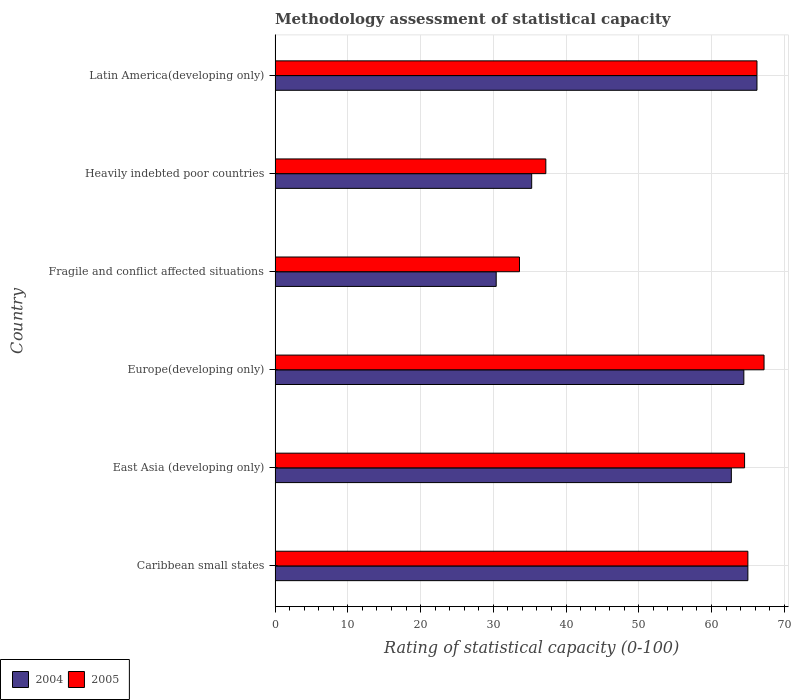Are the number of bars on each tick of the Y-axis equal?
Your answer should be very brief. Yes. How many bars are there on the 4th tick from the top?
Ensure brevity in your answer.  2. What is the label of the 6th group of bars from the top?
Offer a terse response. Caribbean small states. What is the rating of statistical capacity in 2004 in East Asia (developing only)?
Ensure brevity in your answer.  62.73. Across all countries, what is the maximum rating of statistical capacity in 2005?
Provide a short and direct response. 67.22. Across all countries, what is the minimum rating of statistical capacity in 2004?
Keep it short and to the point. 30.4. In which country was the rating of statistical capacity in 2005 maximum?
Make the answer very short. Europe(developing only). In which country was the rating of statistical capacity in 2005 minimum?
Offer a terse response. Fragile and conflict affected situations. What is the total rating of statistical capacity in 2004 in the graph?
Provide a short and direct response. 324.1. What is the difference between the rating of statistical capacity in 2004 in Fragile and conflict affected situations and that in Latin America(developing only)?
Ensure brevity in your answer.  -35.85. What is the difference between the rating of statistical capacity in 2005 in Europe(developing only) and the rating of statistical capacity in 2004 in Fragile and conflict affected situations?
Offer a very short reply. 36.82. What is the average rating of statistical capacity in 2005 per country?
Your response must be concise. 55.64. What is the difference between the rating of statistical capacity in 2004 and rating of statistical capacity in 2005 in Heavily indebted poor countries?
Your answer should be very brief. -1.94. In how many countries, is the rating of statistical capacity in 2004 greater than 56 ?
Your answer should be compact. 4. What is the ratio of the rating of statistical capacity in 2004 in East Asia (developing only) to that in Europe(developing only)?
Your response must be concise. 0.97. What is the difference between the highest and the lowest rating of statistical capacity in 2005?
Keep it short and to the point. 33.62. What does the 1st bar from the bottom in Latin America(developing only) represents?
Offer a terse response. 2004. How many countries are there in the graph?
Offer a very short reply. 6. Are the values on the major ticks of X-axis written in scientific E-notation?
Your answer should be compact. No. Does the graph contain any zero values?
Provide a succinct answer. No. Does the graph contain grids?
Provide a succinct answer. Yes. What is the title of the graph?
Ensure brevity in your answer.  Methodology assessment of statistical capacity. What is the label or title of the X-axis?
Give a very brief answer. Rating of statistical capacity (0-100). What is the label or title of the Y-axis?
Offer a terse response. Country. What is the Rating of statistical capacity (0-100) of 2005 in Caribbean small states?
Provide a succinct answer. 65. What is the Rating of statistical capacity (0-100) of 2004 in East Asia (developing only)?
Your response must be concise. 62.73. What is the Rating of statistical capacity (0-100) in 2005 in East Asia (developing only)?
Keep it short and to the point. 64.55. What is the Rating of statistical capacity (0-100) of 2004 in Europe(developing only)?
Ensure brevity in your answer.  64.44. What is the Rating of statistical capacity (0-100) of 2005 in Europe(developing only)?
Give a very brief answer. 67.22. What is the Rating of statistical capacity (0-100) in 2004 in Fragile and conflict affected situations?
Give a very brief answer. 30.4. What is the Rating of statistical capacity (0-100) in 2005 in Fragile and conflict affected situations?
Your answer should be very brief. 33.6. What is the Rating of statistical capacity (0-100) of 2004 in Heavily indebted poor countries?
Keep it short and to the point. 35.28. What is the Rating of statistical capacity (0-100) in 2005 in Heavily indebted poor countries?
Your answer should be compact. 37.22. What is the Rating of statistical capacity (0-100) of 2004 in Latin America(developing only)?
Ensure brevity in your answer.  66.25. What is the Rating of statistical capacity (0-100) of 2005 in Latin America(developing only)?
Keep it short and to the point. 66.25. Across all countries, what is the maximum Rating of statistical capacity (0-100) of 2004?
Keep it short and to the point. 66.25. Across all countries, what is the maximum Rating of statistical capacity (0-100) of 2005?
Provide a short and direct response. 67.22. Across all countries, what is the minimum Rating of statistical capacity (0-100) of 2004?
Your answer should be very brief. 30.4. Across all countries, what is the minimum Rating of statistical capacity (0-100) in 2005?
Make the answer very short. 33.6. What is the total Rating of statistical capacity (0-100) of 2004 in the graph?
Give a very brief answer. 324.1. What is the total Rating of statistical capacity (0-100) of 2005 in the graph?
Ensure brevity in your answer.  333.84. What is the difference between the Rating of statistical capacity (0-100) in 2004 in Caribbean small states and that in East Asia (developing only)?
Your answer should be compact. 2.27. What is the difference between the Rating of statistical capacity (0-100) of 2005 in Caribbean small states and that in East Asia (developing only)?
Keep it short and to the point. 0.45. What is the difference between the Rating of statistical capacity (0-100) in 2004 in Caribbean small states and that in Europe(developing only)?
Your answer should be compact. 0.56. What is the difference between the Rating of statistical capacity (0-100) of 2005 in Caribbean small states and that in Europe(developing only)?
Your answer should be compact. -2.22. What is the difference between the Rating of statistical capacity (0-100) in 2004 in Caribbean small states and that in Fragile and conflict affected situations?
Give a very brief answer. 34.6. What is the difference between the Rating of statistical capacity (0-100) of 2005 in Caribbean small states and that in Fragile and conflict affected situations?
Your response must be concise. 31.4. What is the difference between the Rating of statistical capacity (0-100) of 2004 in Caribbean small states and that in Heavily indebted poor countries?
Make the answer very short. 29.72. What is the difference between the Rating of statistical capacity (0-100) of 2005 in Caribbean small states and that in Heavily indebted poor countries?
Make the answer very short. 27.78. What is the difference between the Rating of statistical capacity (0-100) in 2004 in Caribbean small states and that in Latin America(developing only)?
Offer a terse response. -1.25. What is the difference between the Rating of statistical capacity (0-100) in 2005 in Caribbean small states and that in Latin America(developing only)?
Provide a short and direct response. -1.25. What is the difference between the Rating of statistical capacity (0-100) in 2004 in East Asia (developing only) and that in Europe(developing only)?
Ensure brevity in your answer.  -1.72. What is the difference between the Rating of statistical capacity (0-100) in 2005 in East Asia (developing only) and that in Europe(developing only)?
Keep it short and to the point. -2.68. What is the difference between the Rating of statistical capacity (0-100) of 2004 in East Asia (developing only) and that in Fragile and conflict affected situations?
Your answer should be very brief. 32.33. What is the difference between the Rating of statistical capacity (0-100) of 2005 in East Asia (developing only) and that in Fragile and conflict affected situations?
Your response must be concise. 30.95. What is the difference between the Rating of statistical capacity (0-100) of 2004 in East Asia (developing only) and that in Heavily indebted poor countries?
Provide a short and direct response. 27.45. What is the difference between the Rating of statistical capacity (0-100) in 2005 in East Asia (developing only) and that in Heavily indebted poor countries?
Provide a succinct answer. 27.32. What is the difference between the Rating of statistical capacity (0-100) of 2004 in East Asia (developing only) and that in Latin America(developing only)?
Make the answer very short. -3.52. What is the difference between the Rating of statistical capacity (0-100) of 2005 in East Asia (developing only) and that in Latin America(developing only)?
Your answer should be very brief. -1.7. What is the difference between the Rating of statistical capacity (0-100) in 2004 in Europe(developing only) and that in Fragile and conflict affected situations?
Your response must be concise. 34.04. What is the difference between the Rating of statistical capacity (0-100) of 2005 in Europe(developing only) and that in Fragile and conflict affected situations?
Offer a terse response. 33.62. What is the difference between the Rating of statistical capacity (0-100) of 2004 in Europe(developing only) and that in Heavily indebted poor countries?
Provide a short and direct response. 29.17. What is the difference between the Rating of statistical capacity (0-100) of 2004 in Europe(developing only) and that in Latin America(developing only)?
Keep it short and to the point. -1.81. What is the difference between the Rating of statistical capacity (0-100) of 2005 in Europe(developing only) and that in Latin America(developing only)?
Your answer should be very brief. 0.97. What is the difference between the Rating of statistical capacity (0-100) in 2004 in Fragile and conflict affected situations and that in Heavily indebted poor countries?
Keep it short and to the point. -4.88. What is the difference between the Rating of statistical capacity (0-100) of 2005 in Fragile and conflict affected situations and that in Heavily indebted poor countries?
Give a very brief answer. -3.62. What is the difference between the Rating of statistical capacity (0-100) in 2004 in Fragile and conflict affected situations and that in Latin America(developing only)?
Give a very brief answer. -35.85. What is the difference between the Rating of statistical capacity (0-100) in 2005 in Fragile and conflict affected situations and that in Latin America(developing only)?
Keep it short and to the point. -32.65. What is the difference between the Rating of statistical capacity (0-100) of 2004 in Heavily indebted poor countries and that in Latin America(developing only)?
Provide a short and direct response. -30.97. What is the difference between the Rating of statistical capacity (0-100) of 2005 in Heavily indebted poor countries and that in Latin America(developing only)?
Offer a terse response. -29.03. What is the difference between the Rating of statistical capacity (0-100) in 2004 in Caribbean small states and the Rating of statistical capacity (0-100) in 2005 in East Asia (developing only)?
Your answer should be very brief. 0.45. What is the difference between the Rating of statistical capacity (0-100) of 2004 in Caribbean small states and the Rating of statistical capacity (0-100) of 2005 in Europe(developing only)?
Ensure brevity in your answer.  -2.22. What is the difference between the Rating of statistical capacity (0-100) of 2004 in Caribbean small states and the Rating of statistical capacity (0-100) of 2005 in Fragile and conflict affected situations?
Give a very brief answer. 31.4. What is the difference between the Rating of statistical capacity (0-100) of 2004 in Caribbean small states and the Rating of statistical capacity (0-100) of 2005 in Heavily indebted poor countries?
Keep it short and to the point. 27.78. What is the difference between the Rating of statistical capacity (0-100) in 2004 in Caribbean small states and the Rating of statistical capacity (0-100) in 2005 in Latin America(developing only)?
Make the answer very short. -1.25. What is the difference between the Rating of statistical capacity (0-100) in 2004 in East Asia (developing only) and the Rating of statistical capacity (0-100) in 2005 in Europe(developing only)?
Your answer should be compact. -4.49. What is the difference between the Rating of statistical capacity (0-100) of 2004 in East Asia (developing only) and the Rating of statistical capacity (0-100) of 2005 in Fragile and conflict affected situations?
Your answer should be compact. 29.13. What is the difference between the Rating of statistical capacity (0-100) in 2004 in East Asia (developing only) and the Rating of statistical capacity (0-100) in 2005 in Heavily indebted poor countries?
Your answer should be compact. 25.51. What is the difference between the Rating of statistical capacity (0-100) in 2004 in East Asia (developing only) and the Rating of statistical capacity (0-100) in 2005 in Latin America(developing only)?
Your answer should be compact. -3.52. What is the difference between the Rating of statistical capacity (0-100) in 2004 in Europe(developing only) and the Rating of statistical capacity (0-100) in 2005 in Fragile and conflict affected situations?
Offer a very short reply. 30.84. What is the difference between the Rating of statistical capacity (0-100) of 2004 in Europe(developing only) and the Rating of statistical capacity (0-100) of 2005 in Heavily indebted poor countries?
Give a very brief answer. 27.22. What is the difference between the Rating of statistical capacity (0-100) of 2004 in Europe(developing only) and the Rating of statistical capacity (0-100) of 2005 in Latin America(developing only)?
Your response must be concise. -1.81. What is the difference between the Rating of statistical capacity (0-100) in 2004 in Fragile and conflict affected situations and the Rating of statistical capacity (0-100) in 2005 in Heavily indebted poor countries?
Keep it short and to the point. -6.82. What is the difference between the Rating of statistical capacity (0-100) of 2004 in Fragile and conflict affected situations and the Rating of statistical capacity (0-100) of 2005 in Latin America(developing only)?
Provide a succinct answer. -35.85. What is the difference between the Rating of statistical capacity (0-100) in 2004 in Heavily indebted poor countries and the Rating of statistical capacity (0-100) in 2005 in Latin America(developing only)?
Ensure brevity in your answer.  -30.97. What is the average Rating of statistical capacity (0-100) in 2004 per country?
Keep it short and to the point. 54.02. What is the average Rating of statistical capacity (0-100) in 2005 per country?
Your answer should be very brief. 55.64. What is the difference between the Rating of statistical capacity (0-100) in 2004 and Rating of statistical capacity (0-100) in 2005 in Caribbean small states?
Your response must be concise. 0. What is the difference between the Rating of statistical capacity (0-100) of 2004 and Rating of statistical capacity (0-100) of 2005 in East Asia (developing only)?
Provide a succinct answer. -1.82. What is the difference between the Rating of statistical capacity (0-100) of 2004 and Rating of statistical capacity (0-100) of 2005 in Europe(developing only)?
Offer a terse response. -2.78. What is the difference between the Rating of statistical capacity (0-100) in 2004 and Rating of statistical capacity (0-100) in 2005 in Fragile and conflict affected situations?
Your answer should be compact. -3.2. What is the difference between the Rating of statistical capacity (0-100) in 2004 and Rating of statistical capacity (0-100) in 2005 in Heavily indebted poor countries?
Offer a terse response. -1.94. What is the ratio of the Rating of statistical capacity (0-100) of 2004 in Caribbean small states to that in East Asia (developing only)?
Your answer should be compact. 1.04. What is the ratio of the Rating of statistical capacity (0-100) of 2004 in Caribbean small states to that in Europe(developing only)?
Your answer should be very brief. 1.01. What is the ratio of the Rating of statistical capacity (0-100) of 2005 in Caribbean small states to that in Europe(developing only)?
Your answer should be very brief. 0.97. What is the ratio of the Rating of statistical capacity (0-100) of 2004 in Caribbean small states to that in Fragile and conflict affected situations?
Offer a terse response. 2.14. What is the ratio of the Rating of statistical capacity (0-100) of 2005 in Caribbean small states to that in Fragile and conflict affected situations?
Your answer should be very brief. 1.93. What is the ratio of the Rating of statistical capacity (0-100) in 2004 in Caribbean small states to that in Heavily indebted poor countries?
Provide a succinct answer. 1.84. What is the ratio of the Rating of statistical capacity (0-100) in 2005 in Caribbean small states to that in Heavily indebted poor countries?
Your answer should be very brief. 1.75. What is the ratio of the Rating of statistical capacity (0-100) of 2004 in Caribbean small states to that in Latin America(developing only)?
Give a very brief answer. 0.98. What is the ratio of the Rating of statistical capacity (0-100) of 2005 in Caribbean small states to that in Latin America(developing only)?
Your answer should be very brief. 0.98. What is the ratio of the Rating of statistical capacity (0-100) in 2004 in East Asia (developing only) to that in Europe(developing only)?
Your response must be concise. 0.97. What is the ratio of the Rating of statistical capacity (0-100) of 2005 in East Asia (developing only) to that in Europe(developing only)?
Provide a succinct answer. 0.96. What is the ratio of the Rating of statistical capacity (0-100) of 2004 in East Asia (developing only) to that in Fragile and conflict affected situations?
Provide a succinct answer. 2.06. What is the ratio of the Rating of statistical capacity (0-100) in 2005 in East Asia (developing only) to that in Fragile and conflict affected situations?
Offer a very short reply. 1.92. What is the ratio of the Rating of statistical capacity (0-100) of 2004 in East Asia (developing only) to that in Heavily indebted poor countries?
Give a very brief answer. 1.78. What is the ratio of the Rating of statistical capacity (0-100) of 2005 in East Asia (developing only) to that in Heavily indebted poor countries?
Make the answer very short. 1.73. What is the ratio of the Rating of statistical capacity (0-100) of 2004 in East Asia (developing only) to that in Latin America(developing only)?
Ensure brevity in your answer.  0.95. What is the ratio of the Rating of statistical capacity (0-100) of 2005 in East Asia (developing only) to that in Latin America(developing only)?
Give a very brief answer. 0.97. What is the ratio of the Rating of statistical capacity (0-100) in 2004 in Europe(developing only) to that in Fragile and conflict affected situations?
Offer a terse response. 2.12. What is the ratio of the Rating of statistical capacity (0-100) in 2005 in Europe(developing only) to that in Fragile and conflict affected situations?
Ensure brevity in your answer.  2. What is the ratio of the Rating of statistical capacity (0-100) in 2004 in Europe(developing only) to that in Heavily indebted poor countries?
Offer a very short reply. 1.83. What is the ratio of the Rating of statistical capacity (0-100) in 2005 in Europe(developing only) to that in Heavily indebted poor countries?
Offer a terse response. 1.81. What is the ratio of the Rating of statistical capacity (0-100) of 2004 in Europe(developing only) to that in Latin America(developing only)?
Keep it short and to the point. 0.97. What is the ratio of the Rating of statistical capacity (0-100) of 2005 in Europe(developing only) to that in Latin America(developing only)?
Provide a succinct answer. 1.01. What is the ratio of the Rating of statistical capacity (0-100) of 2004 in Fragile and conflict affected situations to that in Heavily indebted poor countries?
Your answer should be compact. 0.86. What is the ratio of the Rating of statistical capacity (0-100) in 2005 in Fragile and conflict affected situations to that in Heavily indebted poor countries?
Provide a succinct answer. 0.9. What is the ratio of the Rating of statistical capacity (0-100) in 2004 in Fragile and conflict affected situations to that in Latin America(developing only)?
Offer a terse response. 0.46. What is the ratio of the Rating of statistical capacity (0-100) of 2005 in Fragile and conflict affected situations to that in Latin America(developing only)?
Provide a short and direct response. 0.51. What is the ratio of the Rating of statistical capacity (0-100) in 2004 in Heavily indebted poor countries to that in Latin America(developing only)?
Provide a short and direct response. 0.53. What is the ratio of the Rating of statistical capacity (0-100) of 2005 in Heavily indebted poor countries to that in Latin America(developing only)?
Provide a succinct answer. 0.56. What is the difference between the highest and the second highest Rating of statistical capacity (0-100) of 2005?
Your response must be concise. 0.97. What is the difference between the highest and the lowest Rating of statistical capacity (0-100) of 2004?
Your answer should be compact. 35.85. What is the difference between the highest and the lowest Rating of statistical capacity (0-100) of 2005?
Ensure brevity in your answer.  33.62. 